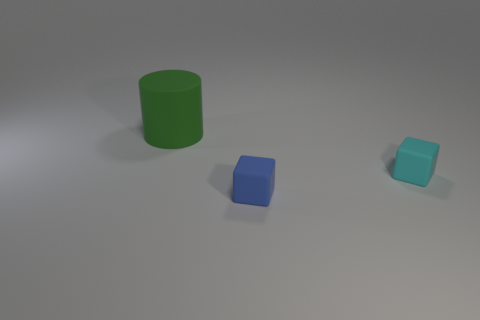Does the small matte cube that is in front of the cyan rubber block have the same color as the tiny matte block that is behind the tiny blue object?
Offer a terse response. No. The matte object that is both behind the blue object and right of the big matte cylinder is what color?
Your answer should be very brief. Cyan. How many other objects are there of the same shape as the large object?
Your response must be concise. 0. What is the color of the other matte thing that is the same size as the cyan rubber thing?
Your answer should be compact. Blue. The block behind the small blue matte block is what color?
Make the answer very short. Cyan. There is a small matte block in front of the tiny cyan rubber cube; is there a cyan block that is in front of it?
Your answer should be compact. No. There is a large green thing; does it have the same shape as the rubber object that is in front of the small cyan thing?
Your response must be concise. No. There is a object that is both on the left side of the tiny cyan matte thing and right of the big cylinder; what is its size?
Give a very brief answer. Small. Is there a purple cube that has the same material as the cyan cube?
Keep it short and to the point. No. There is a block that is to the left of the tiny cube that is on the right side of the blue object; what is its material?
Keep it short and to the point. Rubber. 